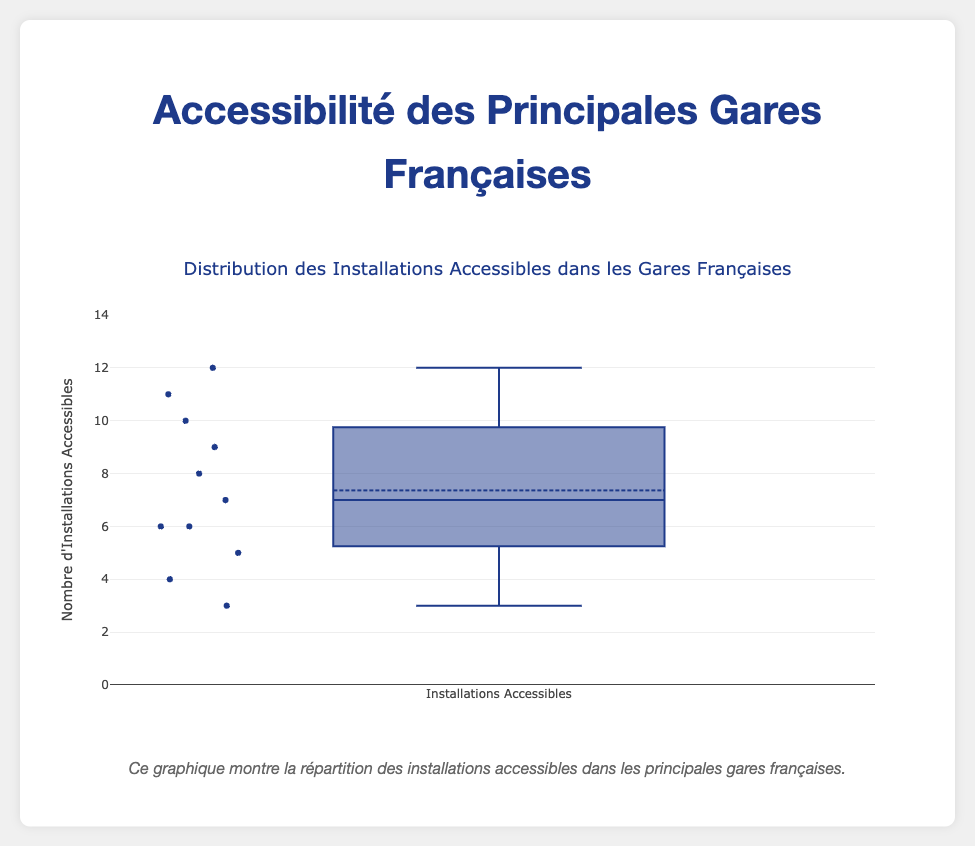What's the title of the plot? The title is usually located at the top of the plot and gives a brief description of what the figure is about. In this case, the title mentions the distribution of accessible facilities in French train stations.
Answer: Distribution des Installations Accessibles dans les Gares Françaises How many train stations are included in this box plot analysis? By interpreting the graphical representation, the count of data points (the small markers within the box plot) indicates the number of train stations. Referring to the provided data, there are 11 stations.
Answer: 11 What is the highest count of accessible facilities recorded for a station in this plot? By looking at the outliers and the top part of the whisker, we can identify the highest count of accessible facilities in the dataset. In this case, it corresponds to Gare du Nord with 12 facilities.
Answer: 12 What is the median number of accessible facilities, and how can you identify it on a box plot? The median value is the line dividing the box into two parts. This line represents the middle value of the dataset. The median in this plot appears to be at the 7-8 mark.
Answer: 8 What is the range of accessible facilities in the train stations? The range is determined by the difference between the maximum and minimum values in the dataset, visible from the whiskers of the box plot. Here, the range is calculated as 12 (maximum) - 3 (minimum).
Answer: 9 How can you identify outliers in a box plot, and are there any outliers in this data? Outliers are shown as individual points beyond the whiskers of the box plot. By examining the plot, any points that are distant from the box are outliers. None of the points in this data appear as distinct outliers.
Answer: No Which station has the fewest accessible facilities, and what is their count? By looking at the bottom of the range in the box plot, the station with the smallest number of accessible facilities can be identified. In this case, Gare d'Avignon TGV has the minimum count, which is 3.
Answer: Gare d'Avignon TGV What is the interquartile range (IQR) of the accessible facilities count? IQR is the difference between the third quartile (Q3) and the first quartile (Q1). By examining the box plot, we can estimate Q1 around 5 and Q3 around 10. Hence, IQR is 10 - 5.
Answer: 5 How does the number of facilities in Gare de Lille-Europe compare to the median number? By identifying the specific count of accessible facilities for Gare de Lille-Europe from the provided data (11) and comparing it with the median value from the box plot (8), we see that Lille-Europe has more facilities than the median.
Answer: More What does the box represent in a box plot? The box itself represents the interquartile range (IQR) which contains the middle 50% of the data. The upper edge corresponds to the 75th percentile (Q3), and the lower edge corresponds to the 25th percentile (Q1). This shows the spread and skewness of the data set.
Answer: Interquartile Range (IQR) 